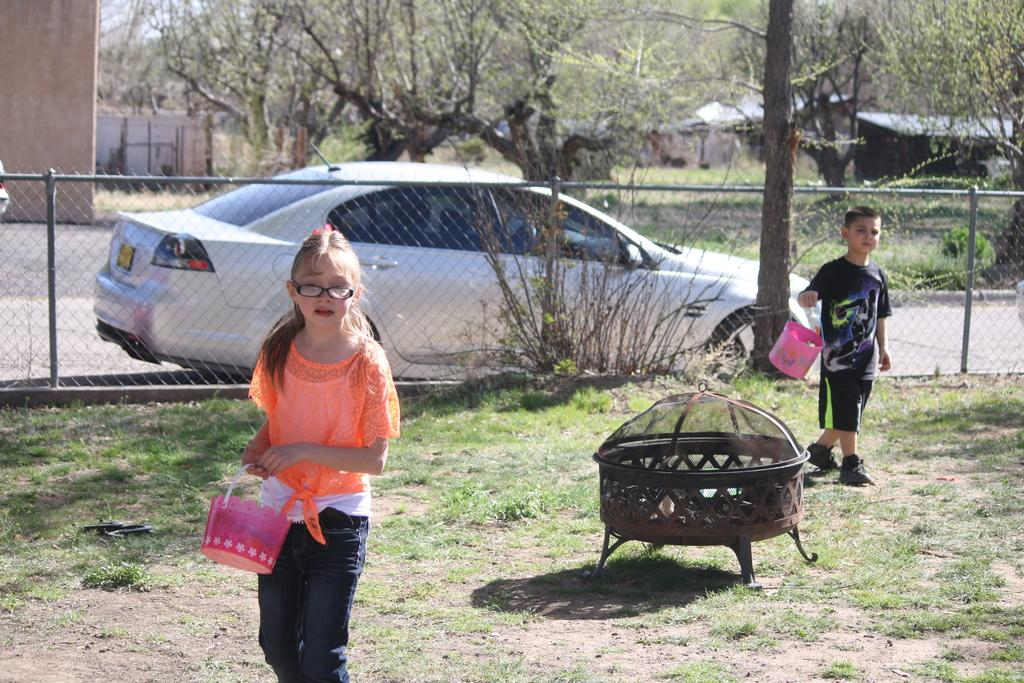How many people are present in the image? There are two people in the image, a boy and a girl. What are the boy and girl doing in the image? Both the boy and girl are standing and holding baskets. What type of environment is depicted in the image? The image features plants, grass, a wire fence, a car on the road, houses, and trees. Can you describe the setting of the image? The setting appears to be outdoors, with a mix of natural and man-made elements. What type of map can be seen in the hands of the boy in the image? There is no map present in the image; the boy is holding a basket. 